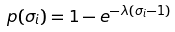Convert formula to latex. <formula><loc_0><loc_0><loc_500><loc_500>p ( \sigma _ { i } ) = 1 - e ^ { - \lambda ( \sigma _ { i } - 1 ) }</formula> 